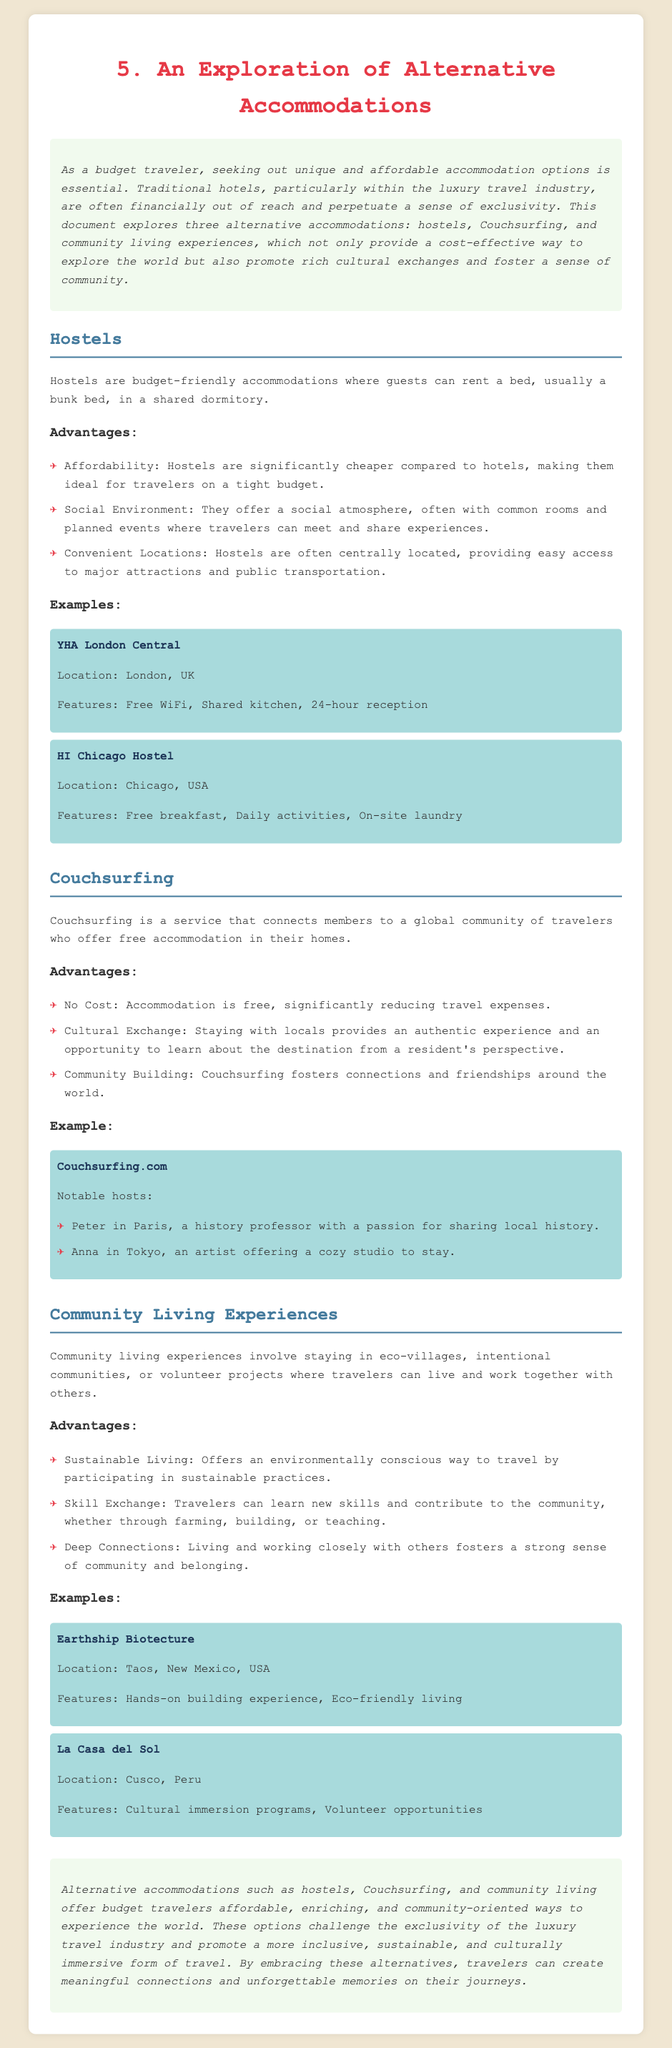What are the three alternative accommodations mentioned? The document lists hostels, Couchsurfing, and community living experiences as alternatives to luxury travel.
Answer: hostels, Couchsurfing, community living experiences What is the advantage of staying in hostels? The document highlights affordability, social environment, and convenient locations as benefits of hostels.
Answer: Affordability Name one feature of YHA London Central. The document states that YHA London Central offers free WiFi among its features.
Answer: Free WiFi What is unique about Couchsurfing? Couchsurfing is characterized by offering free accommodation in people's homes, fostering cultural exchanges.
Answer: Free accommodation What location is associated with Earthship Biotecture? Earthship Biotecture is located in Taos, New Mexico, USA, according to the document.
Answer: Taos, New Mexico, USA How does community living benefit travelers? The document mentions sustainable living as a significant advantage of community living experiences.
Answer: Sustainable Living What type of experience does Couchsurfing promote? Couchsurfing promotes cultural exchange and community building through connections with locals.
Answer: Cultural exchange What is one feature of La Casa del Sol? The document notes cultural immersion programs as a feature of La Casa del Sol.
Answer: Cultural immersion programs 